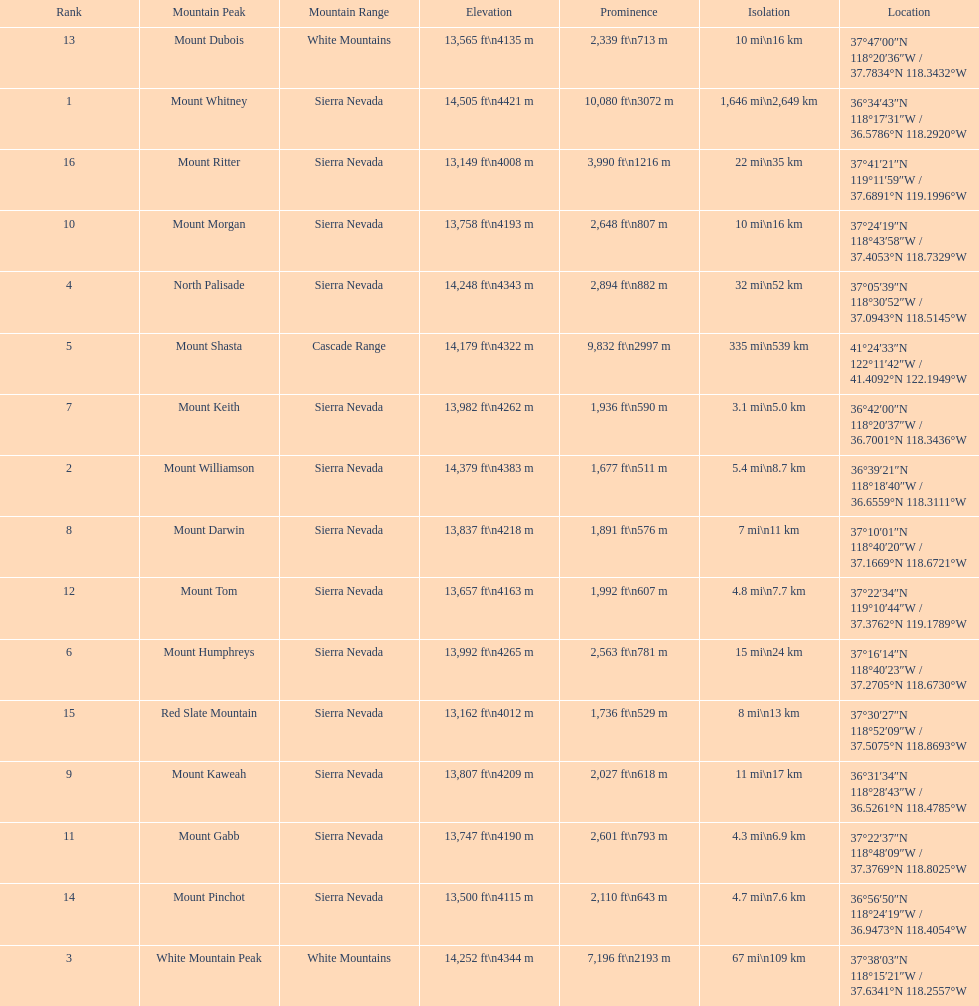What is the next highest mountain peak after north palisade? Mount Shasta. 